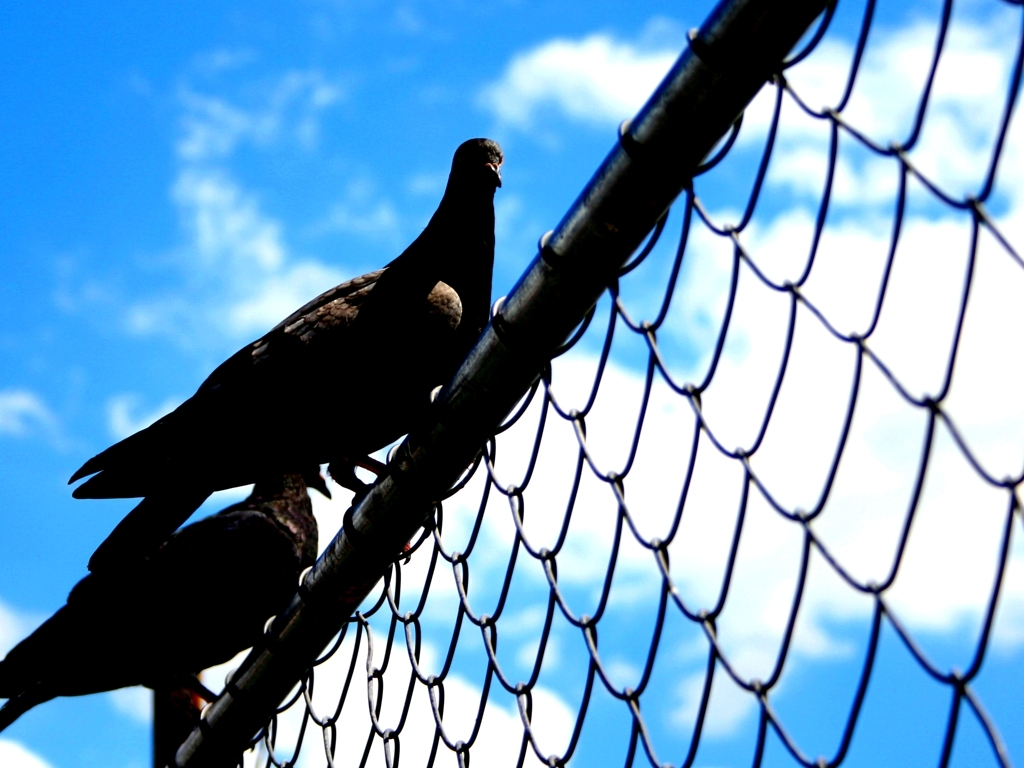What does the lighting and color in the background tell us about the time of day or the weather when this photo was taken? The image presents a background of a vivid blue sky with a few scattered clouds, suggesting it is a clear day. The brightness and the blue hue of the sky hint at the photo being taken during the day, most likely midday when the sun illuminates the sky most vibrantly. The absence of any grey or ominous clouds suggests fair weather at the time of capture. 